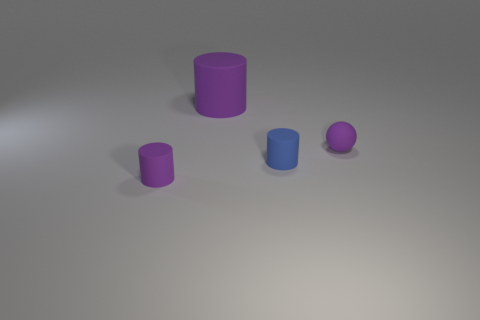Add 2 small cyan metal spheres. How many objects exist? 6 Subtract all balls. How many objects are left? 3 Subtract all big purple objects. Subtract all tiny purple spheres. How many objects are left? 2 Add 3 blue objects. How many blue objects are left? 4 Add 2 spheres. How many spheres exist? 3 Subtract 0 purple cubes. How many objects are left? 4 